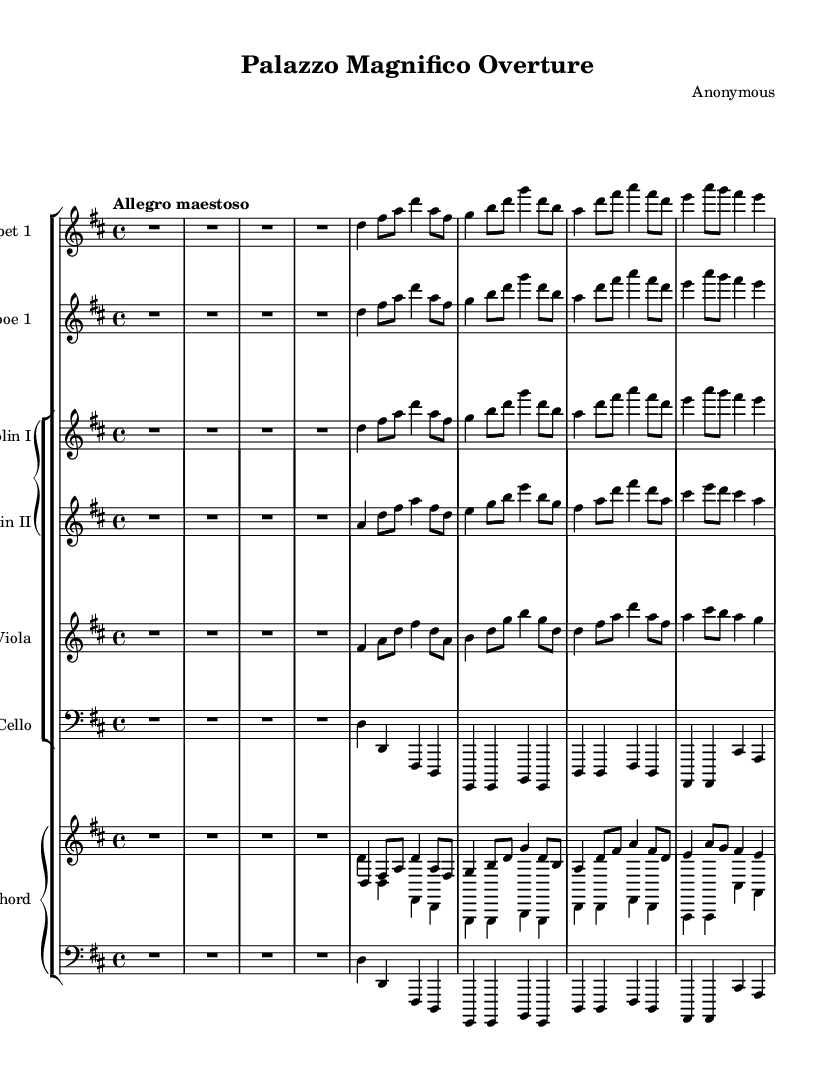What is the key signature of this music? The key signature is indicated by the two sharps at the beginning of the staff after the clef. This corresponds to D major, which has F# and C#.
Answer: D major What is the time signature of this music? The time signature is displayed at the start of the piece, with the upper number indicating beats per measure and the lower number indicating the note value that gets one beat. Here, it shows 4 over 4, which means there are four beats per measure, and a quarter note gets one beat.
Answer: 4/4 What is the tempo marking of this music? The tempo marking is found above the staff, stating "Allegro maestoso," which describes the speed and style in which the piece should be played. "Allegro" indicates a lively and fast tempo, while "maestoso" suggests a majestic and grand character.
Answer: Allegro maestoso How many instruments are included in this composition? By counting the individual staves in the score, we see parts for Trumpet, Oboe, Violin I, Violin II, Viola, Cello, and Harpsichord. This totals seven distinct musical instruments in the piece.
Answer: Seven What is the primary texture of the overture? This piece features a combination of, typically, melody and accompaniment, often layered with counterpoint. The interplay between the instruments creates a rich texture typical of Baroque music, primarily reflecting a polyphonic style.
Answer: Polyphonic Which period of music does this overture represent? The distinct features of the musical piece, including the instrumentation, form, and ornamentation, align with characteristics of the Baroque period, which spanned from approximately 1600 to 1750.
Answer: Baroque 